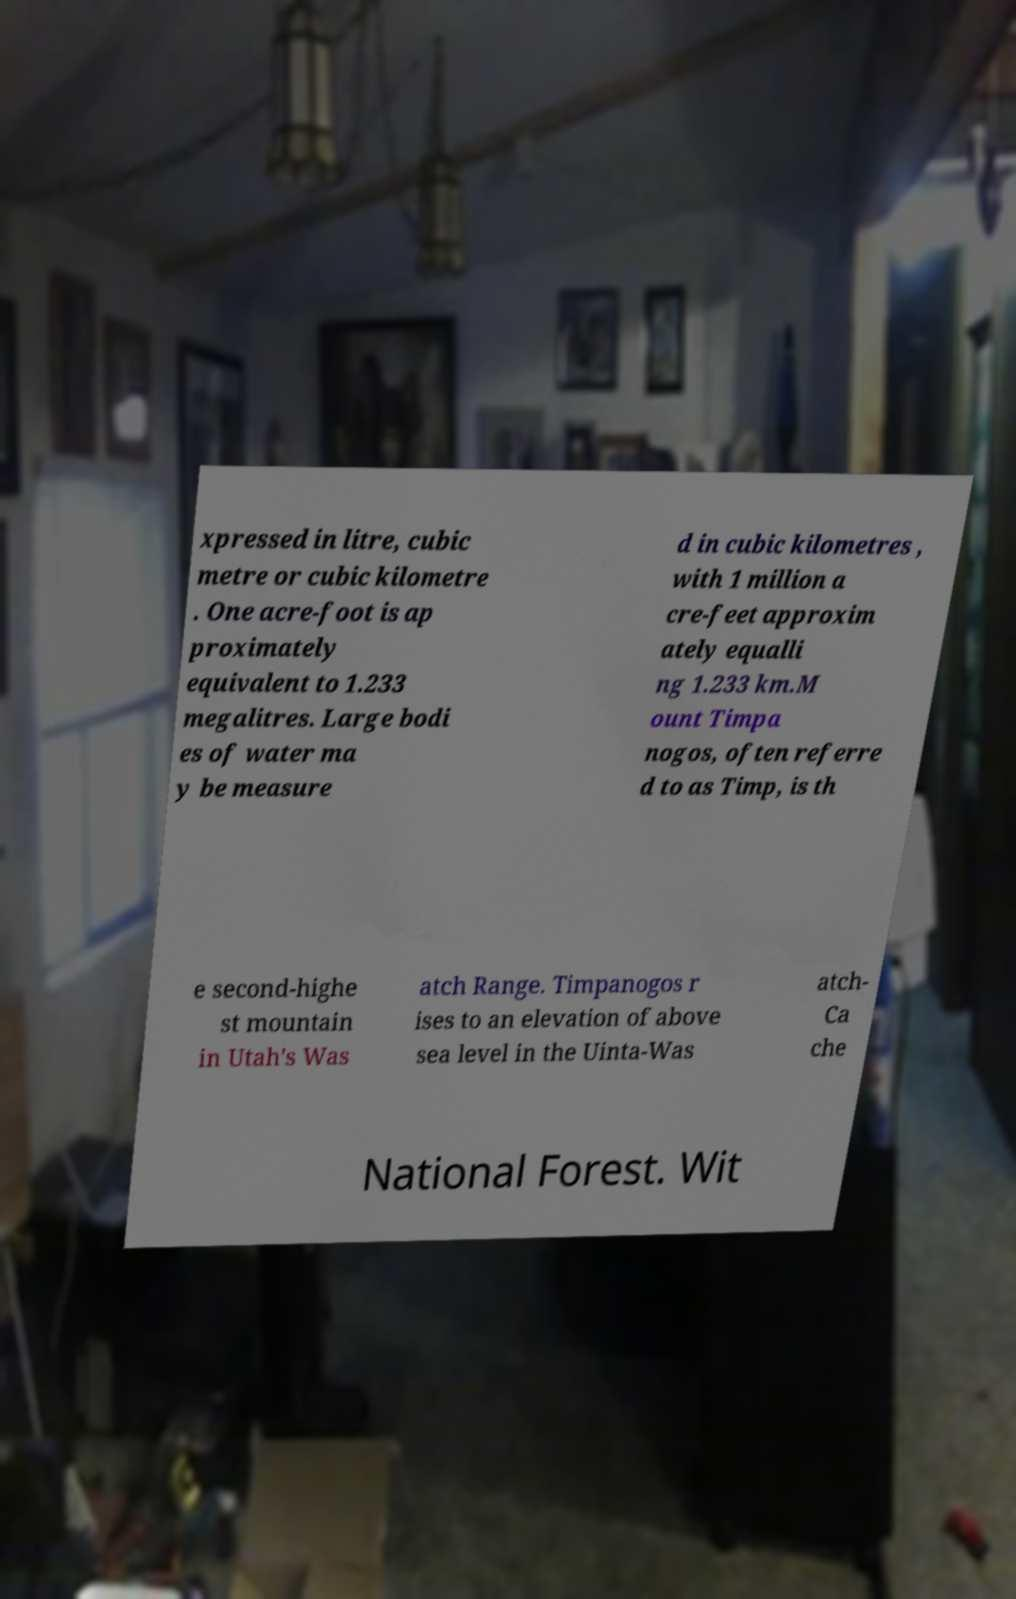I need the written content from this picture converted into text. Can you do that? xpressed in litre, cubic metre or cubic kilometre . One acre-foot is ap proximately equivalent to 1.233 megalitres. Large bodi es of water ma y be measure d in cubic kilometres , with 1 million a cre-feet approxim ately equalli ng 1.233 km.M ount Timpa nogos, often referre d to as Timp, is th e second-highe st mountain in Utah's Was atch Range. Timpanogos r ises to an elevation of above sea level in the Uinta-Was atch- Ca che National Forest. Wit 